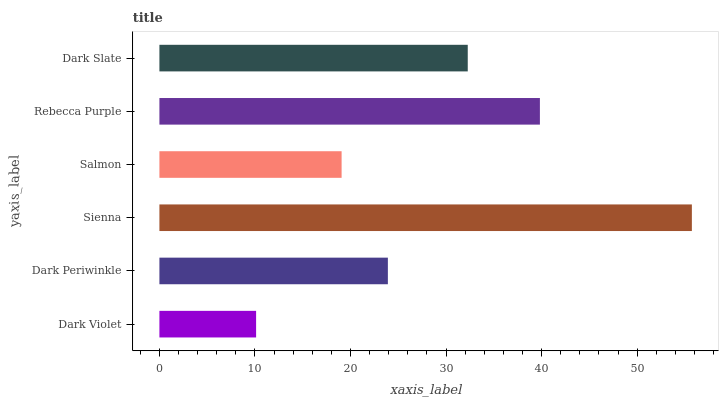Is Dark Violet the minimum?
Answer yes or no. Yes. Is Sienna the maximum?
Answer yes or no. Yes. Is Dark Periwinkle the minimum?
Answer yes or no. No. Is Dark Periwinkle the maximum?
Answer yes or no. No. Is Dark Periwinkle greater than Dark Violet?
Answer yes or no. Yes. Is Dark Violet less than Dark Periwinkle?
Answer yes or no. Yes. Is Dark Violet greater than Dark Periwinkle?
Answer yes or no. No. Is Dark Periwinkle less than Dark Violet?
Answer yes or no. No. Is Dark Slate the high median?
Answer yes or no. Yes. Is Dark Periwinkle the low median?
Answer yes or no. Yes. Is Salmon the high median?
Answer yes or no. No. Is Rebecca Purple the low median?
Answer yes or no. No. 